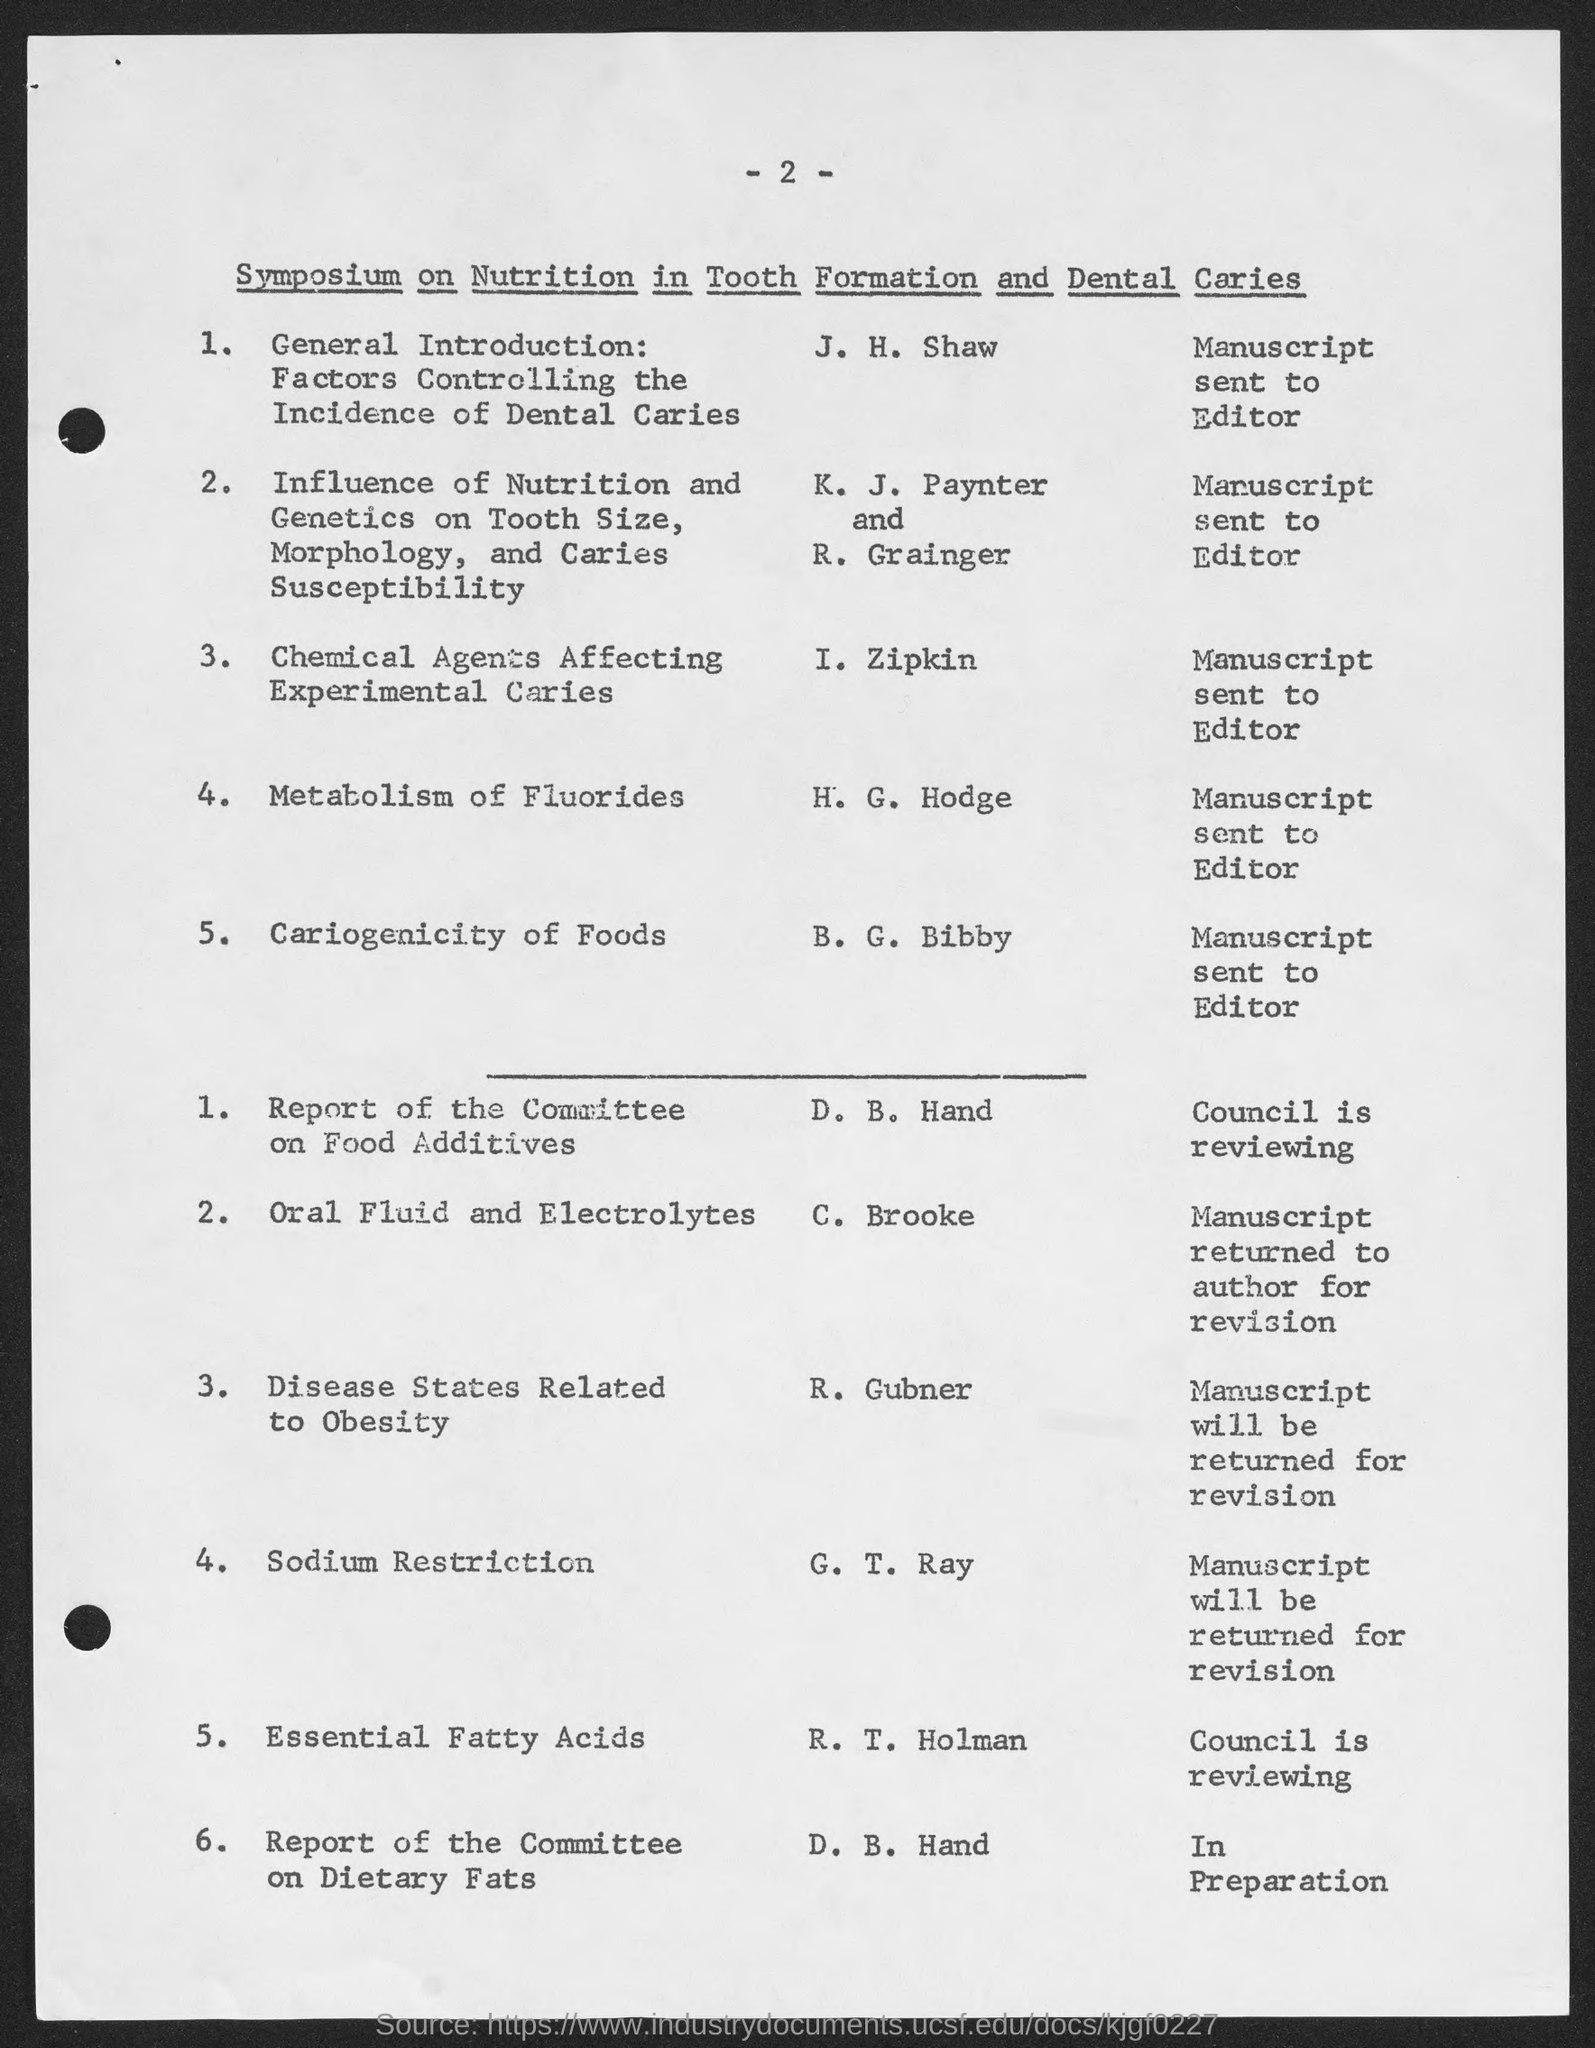What is the number at top of the page ?
Your answer should be compact. -2-. 